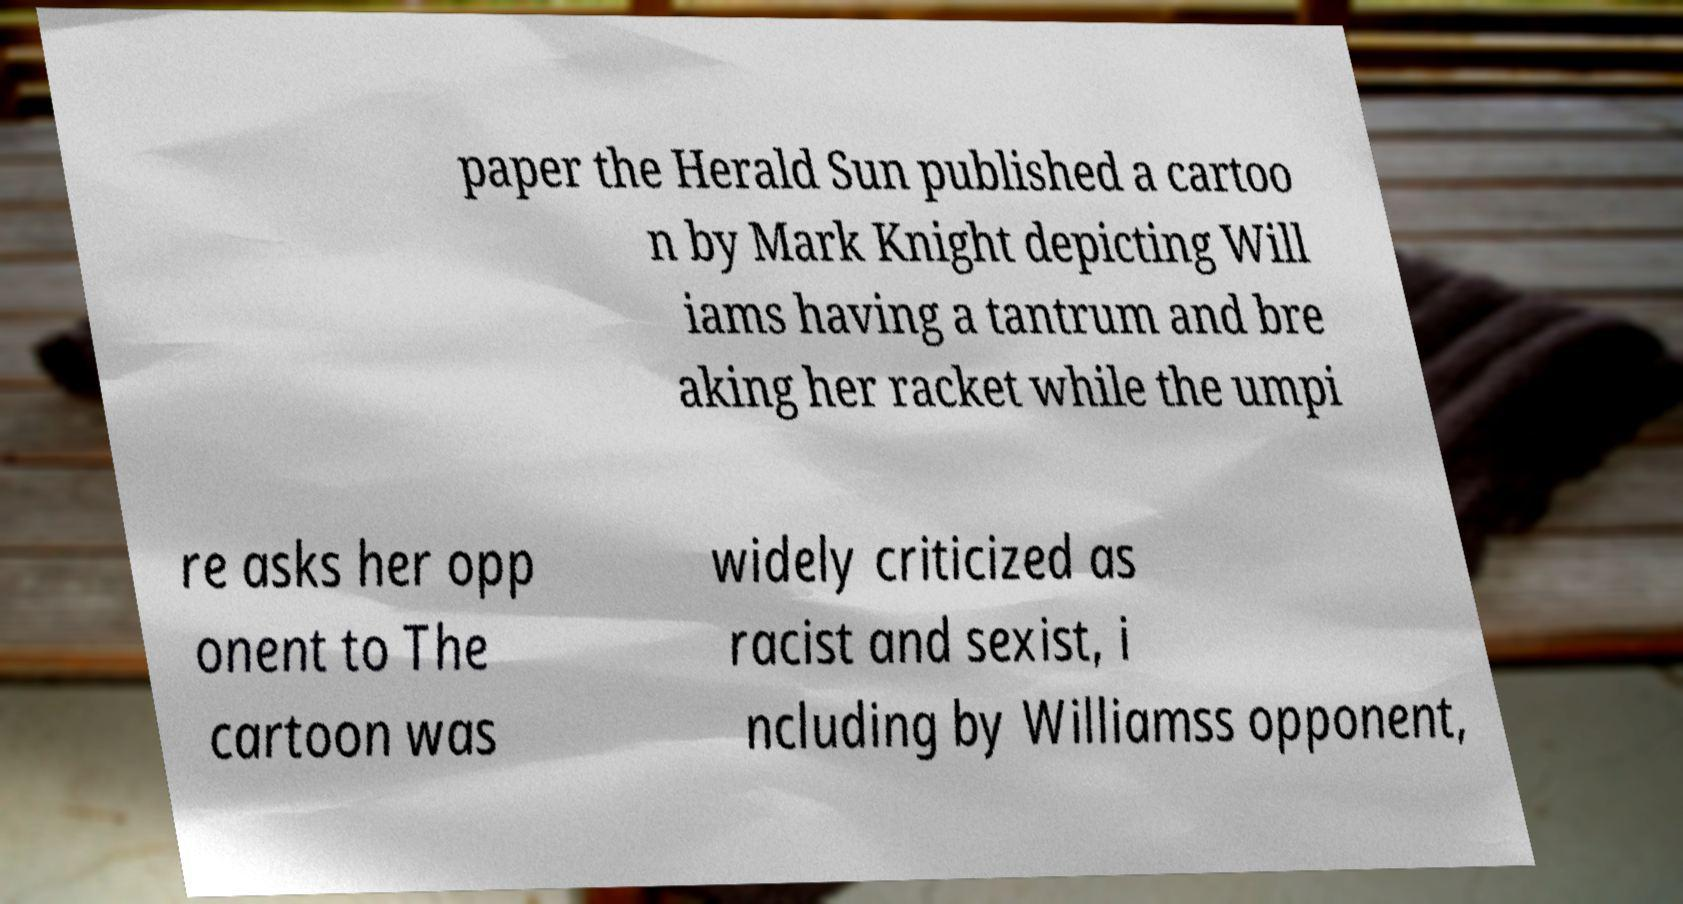Could you extract and type out the text from this image? paper the Herald Sun published a cartoo n by Mark Knight depicting Will iams having a tantrum and bre aking her racket while the umpi re asks her opp onent to The cartoon was widely criticized as racist and sexist, i ncluding by Williamss opponent, 